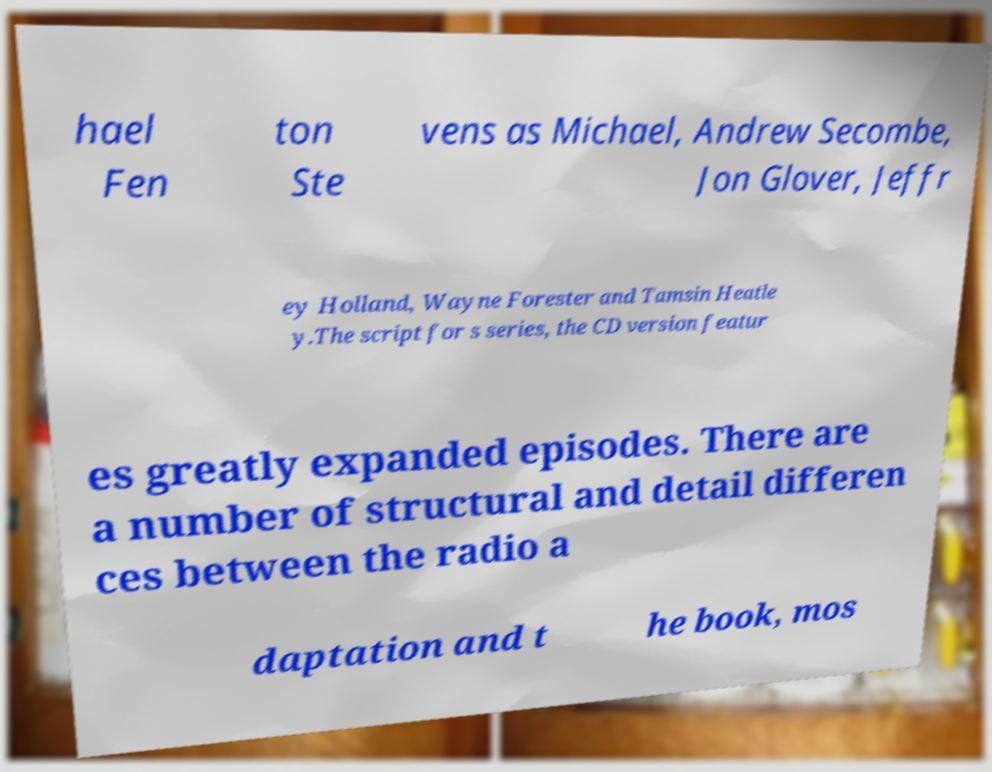Can you accurately transcribe the text from the provided image for me? hael Fen ton Ste vens as Michael, Andrew Secombe, Jon Glover, Jeffr ey Holland, Wayne Forester and Tamsin Heatle y.The script for s series, the CD version featur es greatly expanded episodes. There are a number of structural and detail differen ces between the radio a daptation and t he book, mos 